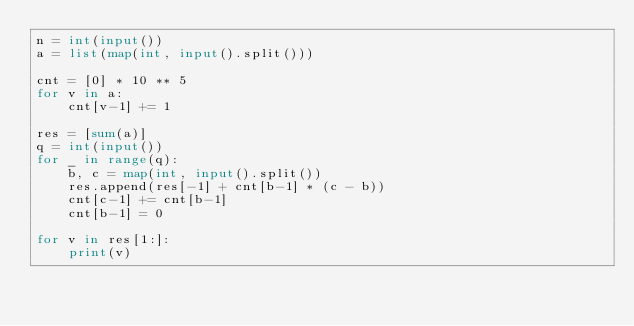Convert code to text. <code><loc_0><loc_0><loc_500><loc_500><_Python_>n = int(input())
a = list(map(int, input().split()))

cnt = [0] * 10 ** 5
for v in a:
    cnt[v-1] += 1

res = [sum(a)]
q = int(input())
for _ in range(q):
    b, c = map(int, input().split())
    res.append(res[-1] + cnt[b-1] * (c - b))
    cnt[c-1] += cnt[b-1]
    cnt[b-1] = 0

for v in res[1:]:
    print(v)</code> 